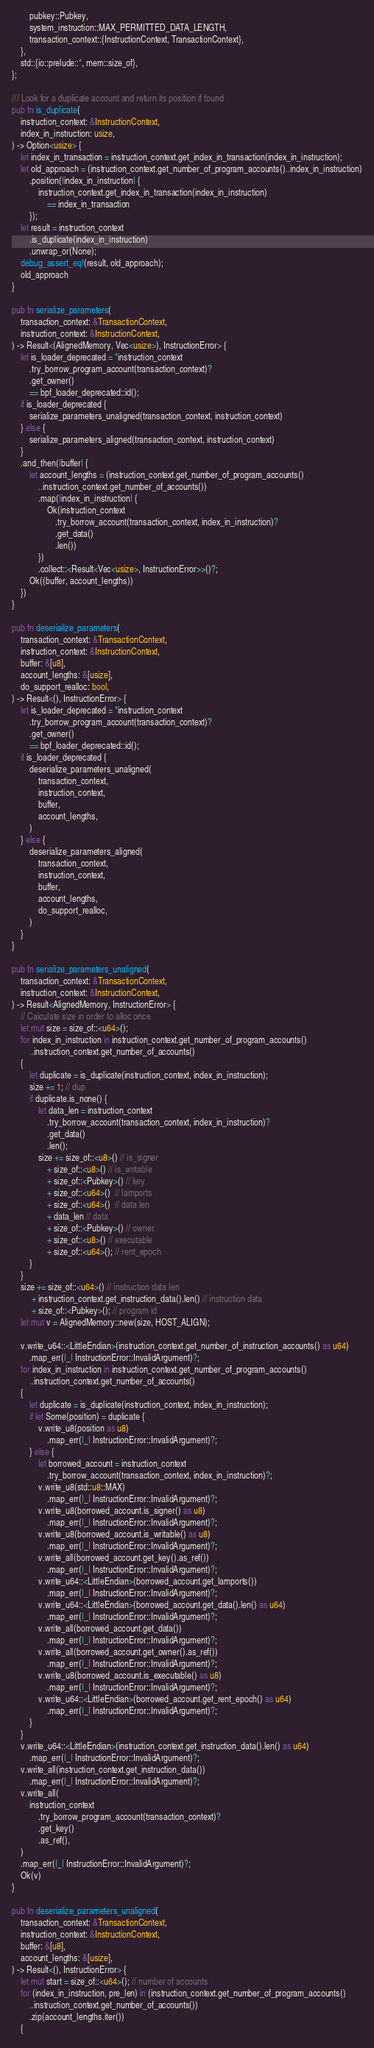<code> <loc_0><loc_0><loc_500><loc_500><_Rust_>        pubkey::Pubkey,
        system_instruction::MAX_PERMITTED_DATA_LENGTH,
        transaction_context::{InstructionContext, TransactionContext},
    },
    std::{io::prelude::*, mem::size_of},
};

/// Look for a duplicate account and return its position if found
pub fn is_duplicate(
    instruction_context: &InstructionContext,
    index_in_instruction: usize,
) -> Option<usize> {
    let index_in_transaction = instruction_context.get_index_in_transaction(index_in_instruction);
    let old_approach = (instruction_context.get_number_of_program_accounts()..index_in_instruction)
        .position(|index_in_instruction| {
            instruction_context.get_index_in_transaction(index_in_instruction)
                == index_in_transaction
        });
    let result = instruction_context
        .is_duplicate(index_in_instruction)
        .unwrap_or(None);
    debug_assert_eq!(result, old_approach);
    old_approach
}

pub fn serialize_parameters(
    transaction_context: &TransactionContext,
    instruction_context: &InstructionContext,
) -> Result<(AlignedMemory, Vec<usize>), InstructionError> {
    let is_loader_deprecated = *instruction_context
        .try_borrow_program_account(transaction_context)?
        .get_owner()
        == bpf_loader_deprecated::id();
    if is_loader_deprecated {
        serialize_parameters_unaligned(transaction_context, instruction_context)
    } else {
        serialize_parameters_aligned(transaction_context, instruction_context)
    }
    .and_then(|buffer| {
        let account_lengths = (instruction_context.get_number_of_program_accounts()
            ..instruction_context.get_number_of_accounts())
            .map(|index_in_instruction| {
                Ok(instruction_context
                    .try_borrow_account(transaction_context, index_in_instruction)?
                    .get_data()
                    .len())
            })
            .collect::<Result<Vec<usize>, InstructionError>>()?;
        Ok((buffer, account_lengths))
    })
}

pub fn deserialize_parameters(
    transaction_context: &TransactionContext,
    instruction_context: &InstructionContext,
    buffer: &[u8],
    account_lengths: &[usize],
    do_support_realloc: bool,
) -> Result<(), InstructionError> {
    let is_loader_deprecated = *instruction_context
        .try_borrow_program_account(transaction_context)?
        .get_owner()
        == bpf_loader_deprecated::id();
    if is_loader_deprecated {
        deserialize_parameters_unaligned(
            transaction_context,
            instruction_context,
            buffer,
            account_lengths,
        )
    } else {
        deserialize_parameters_aligned(
            transaction_context,
            instruction_context,
            buffer,
            account_lengths,
            do_support_realloc,
        )
    }
}

pub fn serialize_parameters_unaligned(
    transaction_context: &TransactionContext,
    instruction_context: &InstructionContext,
) -> Result<AlignedMemory, InstructionError> {
    // Calculate size in order to alloc once
    let mut size = size_of::<u64>();
    for index_in_instruction in instruction_context.get_number_of_program_accounts()
        ..instruction_context.get_number_of_accounts()
    {
        let duplicate = is_duplicate(instruction_context, index_in_instruction);
        size += 1; // dup
        if duplicate.is_none() {
            let data_len = instruction_context
                .try_borrow_account(transaction_context, index_in_instruction)?
                .get_data()
                .len();
            size += size_of::<u8>() // is_signer
                + size_of::<u8>() // is_writable
                + size_of::<Pubkey>() // key
                + size_of::<u64>()  // lamports
                + size_of::<u64>()  // data len
                + data_len // data
                + size_of::<Pubkey>() // owner
                + size_of::<u8>() // executable
                + size_of::<u64>(); // rent_epoch
        }
    }
    size += size_of::<u64>() // instruction data len
         + instruction_context.get_instruction_data().len() // instruction data
         + size_of::<Pubkey>(); // program id
    let mut v = AlignedMemory::new(size, HOST_ALIGN);

    v.write_u64::<LittleEndian>(instruction_context.get_number_of_instruction_accounts() as u64)
        .map_err(|_| InstructionError::InvalidArgument)?;
    for index_in_instruction in instruction_context.get_number_of_program_accounts()
        ..instruction_context.get_number_of_accounts()
    {
        let duplicate = is_duplicate(instruction_context, index_in_instruction);
        if let Some(position) = duplicate {
            v.write_u8(position as u8)
                .map_err(|_| InstructionError::InvalidArgument)?;
        } else {
            let borrowed_account = instruction_context
                .try_borrow_account(transaction_context, index_in_instruction)?;
            v.write_u8(std::u8::MAX)
                .map_err(|_| InstructionError::InvalidArgument)?;
            v.write_u8(borrowed_account.is_signer() as u8)
                .map_err(|_| InstructionError::InvalidArgument)?;
            v.write_u8(borrowed_account.is_writable() as u8)
                .map_err(|_| InstructionError::InvalidArgument)?;
            v.write_all(borrowed_account.get_key().as_ref())
                .map_err(|_| InstructionError::InvalidArgument)?;
            v.write_u64::<LittleEndian>(borrowed_account.get_lamports())
                .map_err(|_| InstructionError::InvalidArgument)?;
            v.write_u64::<LittleEndian>(borrowed_account.get_data().len() as u64)
                .map_err(|_| InstructionError::InvalidArgument)?;
            v.write_all(borrowed_account.get_data())
                .map_err(|_| InstructionError::InvalidArgument)?;
            v.write_all(borrowed_account.get_owner().as_ref())
                .map_err(|_| InstructionError::InvalidArgument)?;
            v.write_u8(borrowed_account.is_executable() as u8)
                .map_err(|_| InstructionError::InvalidArgument)?;
            v.write_u64::<LittleEndian>(borrowed_account.get_rent_epoch() as u64)
                .map_err(|_| InstructionError::InvalidArgument)?;
        }
    }
    v.write_u64::<LittleEndian>(instruction_context.get_instruction_data().len() as u64)
        .map_err(|_| InstructionError::InvalidArgument)?;
    v.write_all(instruction_context.get_instruction_data())
        .map_err(|_| InstructionError::InvalidArgument)?;
    v.write_all(
        instruction_context
            .try_borrow_program_account(transaction_context)?
            .get_key()
            .as_ref(),
    )
    .map_err(|_| InstructionError::InvalidArgument)?;
    Ok(v)
}

pub fn deserialize_parameters_unaligned(
    transaction_context: &TransactionContext,
    instruction_context: &InstructionContext,
    buffer: &[u8],
    account_lengths: &[usize],
) -> Result<(), InstructionError> {
    let mut start = size_of::<u64>(); // number of accounts
    for (index_in_instruction, pre_len) in (instruction_context.get_number_of_program_accounts()
        ..instruction_context.get_number_of_accounts())
        .zip(account_lengths.iter())
    {</code> 